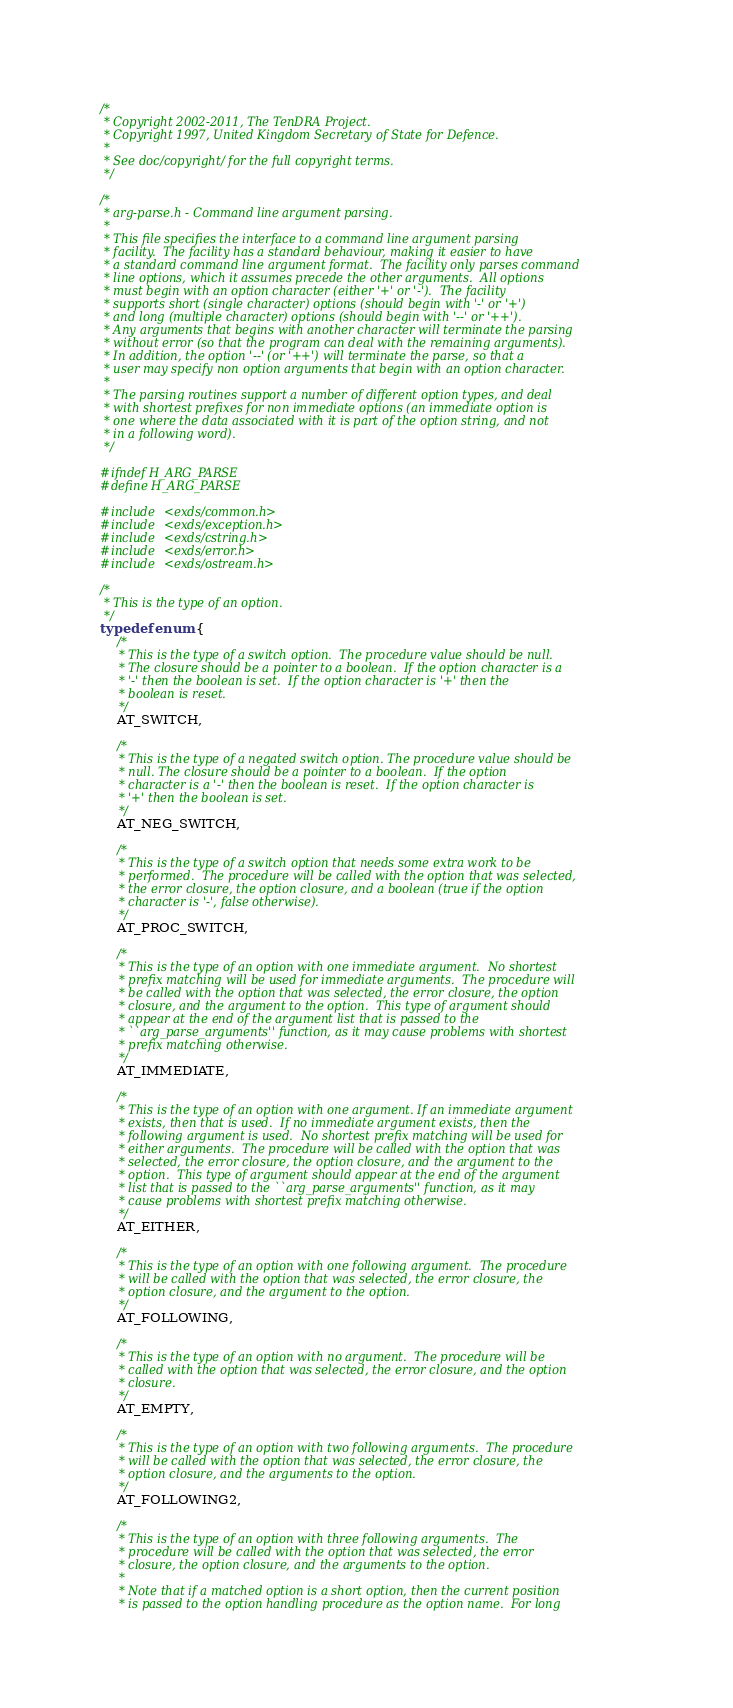Convert code to text. <code><loc_0><loc_0><loc_500><loc_500><_C_>/*
 * Copyright 2002-2011, The TenDRA Project.
 * Copyright 1997, United Kingdom Secretary of State for Defence.
 *
 * See doc/copyright/ for the full copyright terms.
 */

/*
 * arg-parse.h - Command line argument parsing.
 *
 * This file specifies the interface to a command line argument parsing
 * facility.  The facility has a standard behaviour, making it easier to have
 * a standard command line argument format.  The facility only parses command
 * line options, which it assumes precede the other arguments.  All options
 * must begin with an option character (either '+' or '-').  The facility
 * supports short (single character) options (should begin with '-' or '+')
 * and long (multiple character) options (should begin with '--' or '++').
 * Any arguments that begins with another character will terminate the parsing
 * without error (so that the program can deal with the remaining arguments).
 * In addition, the option '--' (or '++') will terminate the parse, so that a
 * user may specify non option arguments that begin with an option character.
 *
 * The parsing routines support a number of different option types, and deal
 * with shortest prefixes for non immediate options (an immediate option is
 * one where the data associated with it is part of the option string, and not
 * in a following word).
 */

#ifndef H_ARG_PARSE
#define H_ARG_PARSE

#include <exds/common.h>
#include <exds/exception.h>
#include <exds/cstring.h>
#include <exds/error.h>
#include <exds/ostream.h>

/*
 * This is the type of an option.
 */
typedef enum {
	/*
	 * This is the type of a switch option.  The procedure value should be null.
	 * The closure should be a pointer to a boolean.  If the option character is a
	 * '-' then the boolean is set.  If the option character is '+' then the
	 * boolean is reset.
	 */
	AT_SWITCH,

	/*
	 * This is the type of a negated switch option. The procedure value should be
	 * null. The closure should be a pointer to a boolean.  If the option
	 * character is a '-' then the boolean is reset.  If the option character is
	 * '+' then the boolean is set.
	 */
	AT_NEG_SWITCH,

	/*
	 * This is the type of a switch option that needs some extra work to be
	 * performed.  The procedure will be called with the option that was selected,
	 * the error closure, the option closure, and a boolean (true if the option
	 * character is '-', false otherwise).
	 */
	AT_PROC_SWITCH,

	/*
	 * This is the type of an option with one immediate argument.  No shortest
	 * prefix matching will be used for immediate arguments.  The procedure will
	 * be called with the option that was selected, the error closure, the option
	 * closure, and the argument to the option.  This type of argument should
	 * appear at the end of the argument list that is passed to the
	 * ``arg_parse_arguments'' function, as it may cause problems with shortest
	 * prefix matching otherwise.
	 */
	AT_IMMEDIATE,

	/*
	 * This is the type of an option with one argument. If an immediate argument
	 * exists, then that is used.  If no immediate argument exists, then the
	 * following argument is used.  No shortest prefix matching will be used for
	 * either arguments.  The procedure will be called with the option that was
	 * selected, the error closure, the option closure, and the argument to the
	 * option.  This type of argument should appear at the end of the argument
	 * list that is passed to the ``arg_parse_arguments'' function, as it may
	 * cause problems with shortest prefix matching otherwise.
	 */
	AT_EITHER,

	/*
	 * This is the type of an option with one following argument.  The procedure
	 * will be called with the option that was selected, the error closure, the
	 * option closure, and the argument to the option.
	 */
	AT_FOLLOWING,

	/*
	 * This is the type of an option with no argument.  The procedure will be
	 * called with the option that was selected, the error closure, and the option
	 * closure.
	 */
	AT_EMPTY,

	/*
	 * This is the type of an option with two following arguments.  The procedure
	 * will be called with the option that was selected, the error closure, the
	 * option closure, and the arguments to the option.
	 */
	AT_FOLLOWING2,

	/*
	 * This is the type of an option with three following arguments.  The
	 * procedure will be called with the option that was selected, the error
	 * closure, the option closure, and the arguments to the option.
	 *
	 * Note that if a matched option is a short option, then the current position
	 * is passed to the option handling procedure as the option name.  For long</code> 